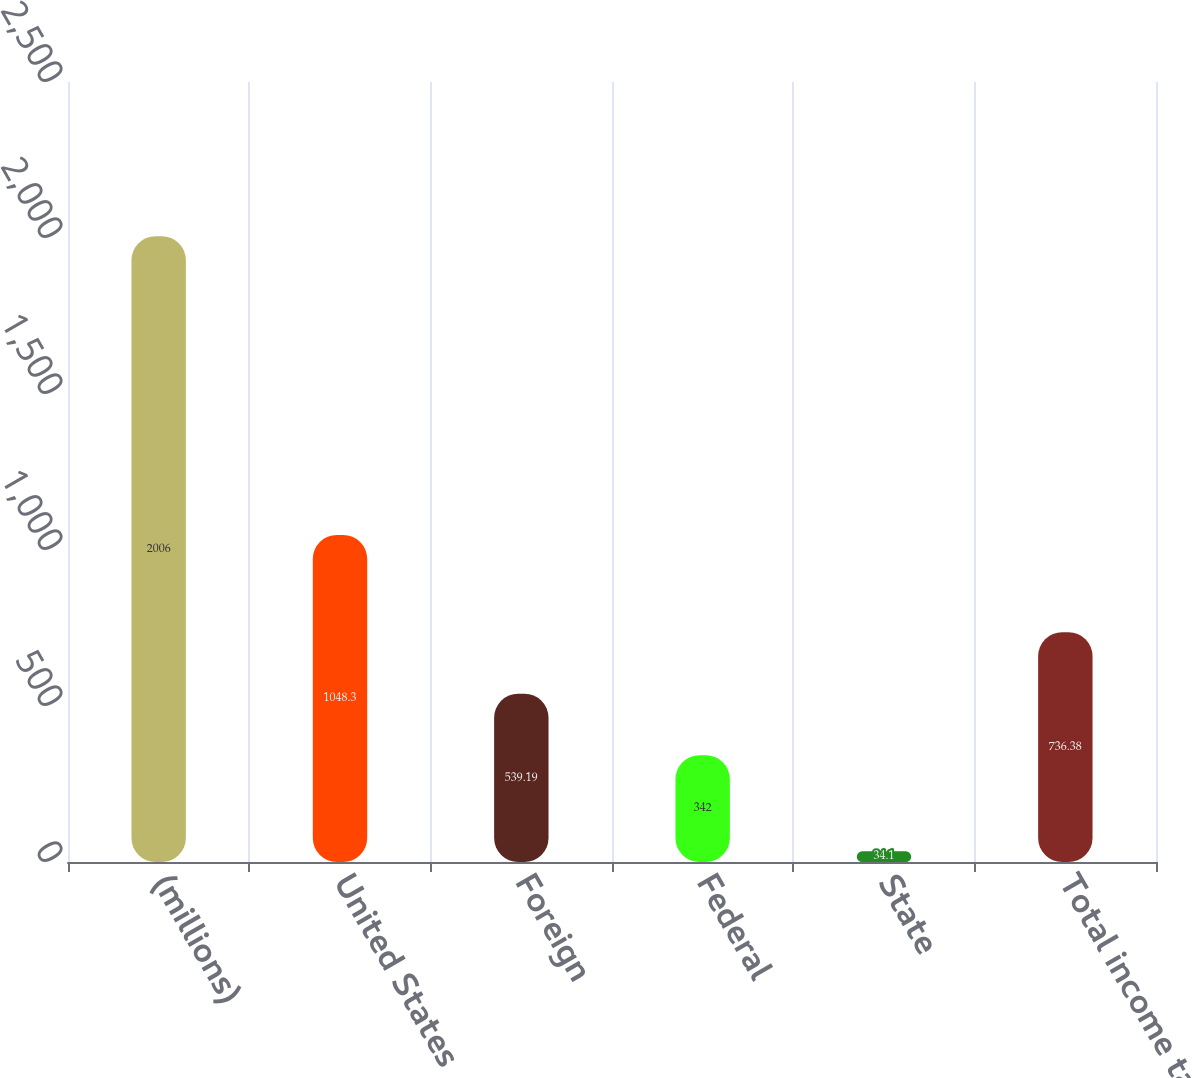Convert chart. <chart><loc_0><loc_0><loc_500><loc_500><bar_chart><fcel>(millions)<fcel>United States<fcel>Foreign<fcel>Federal<fcel>State<fcel>Total income taxes<nl><fcel>2006<fcel>1048.3<fcel>539.19<fcel>342<fcel>34.1<fcel>736.38<nl></chart> 